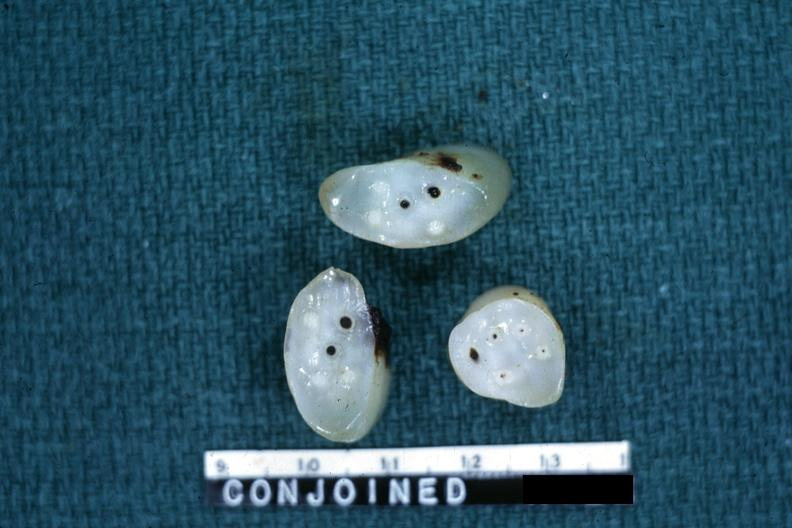where does this belong to?
Answer the question using a single word or phrase. Female reproductive system 